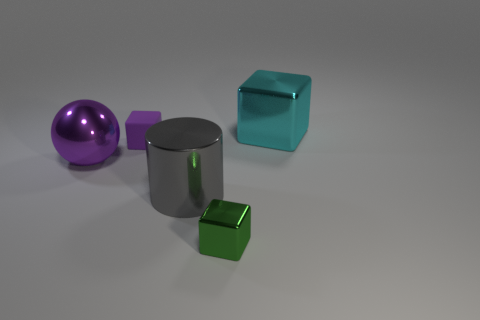Subtract all cyan metallic blocks. How many blocks are left? 2 Subtract all green cubes. How many cubes are left? 2 Subtract all brown balls. How many green blocks are left? 1 Subtract all tiny brown rubber objects. Subtract all green cubes. How many objects are left? 4 Add 2 objects. How many objects are left? 7 Add 1 matte cubes. How many matte cubes exist? 2 Add 2 tiny green metallic cylinders. How many objects exist? 7 Subtract 0 yellow cylinders. How many objects are left? 5 Subtract all cubes. How many objects are left? 2 Subtract all yellow cubes. Subtract all brown cylinders. How many cubes are left? 3 